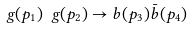Convert formula to latex. <formula><loc_0><loc_0><loc_500><loc_500>\ g ( p _ { 1 } ) \ g ( p _ { 2 } ) \to b ( p _ { 3 } ) \bar { b } ( p _ { 4 } )</formula> 